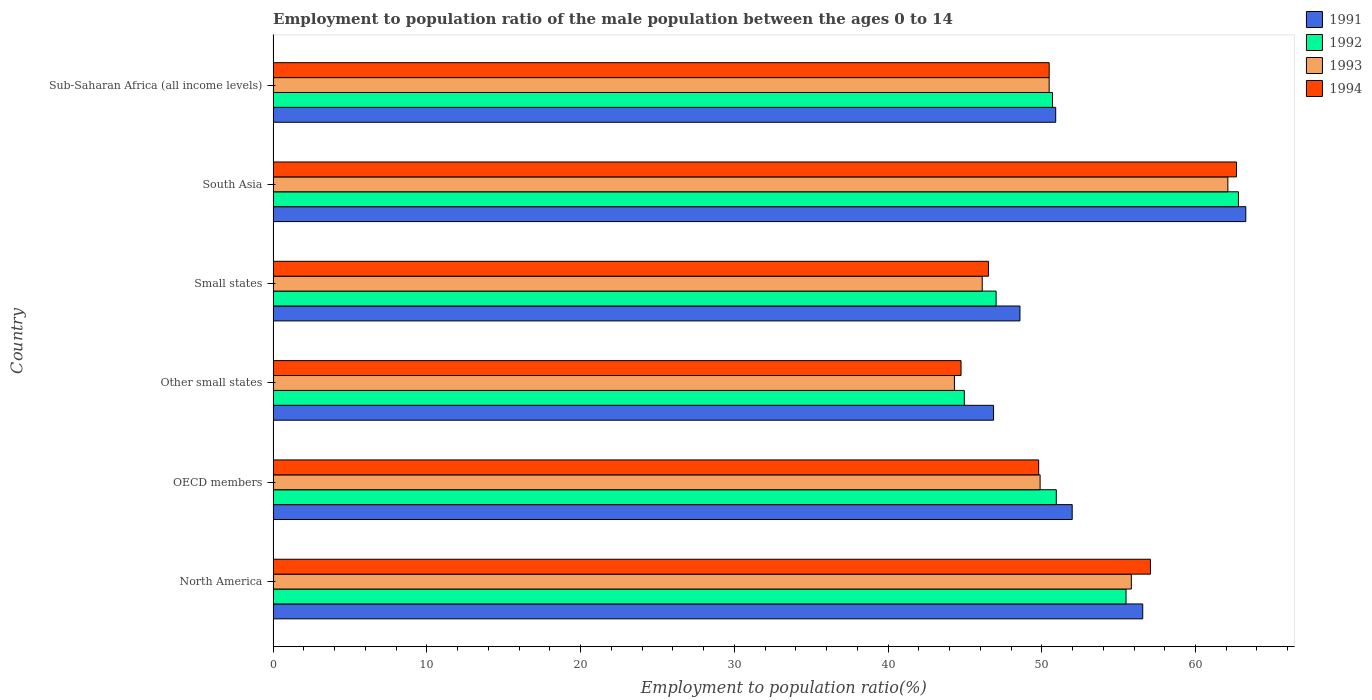How many different coloured bars are there?
Make the answer very short. 4. How many groups of bars are there?
Provide a succinct answer. 6. Are the number of bars on each tick of the Y-axis equal?
Your answer should be very brief. Yes. How many bars are there on the 3rd tick from the top?
Your answer should be very brief. 4. What is the label of the 3rd group of bars from the top?
Provide a short and direct response. Small states. What is the employment to population ratio in 1991 in Small states?
Ensure brevity in your answer.  48.58. Across all countries, what is the maximum employment to population ratio in 1991?
Ensure brevity in your answer.  63.27. Across all countries, what is the minimum employment to population ratio in 1991?
Make the answer very short. 46.86. In which country was the employment to population ratio in 1993 minimum?
Ensure brevity in your answer.  Other small states. What is the total employment to population ratio in 1992 in the graph?
Your answer should be very brief. 311.92. What is the difference between the employment to population ratio in 1992 in OECD members and that in Sub-Saharan Africa (all income levels)?
Offer a very short reply. 0.25. What is the difference between the employment to population ratio in 1991 in OECD members and the employment to population ratio in 1993 in Small states?
Keep it short and to the point. 5.85. What is the average employment to population ratio in 1993 per country?
Keep it short and to the point. 51.46. What is the difference between the employment to population ratio in 1992 and employment to population ratio in 1991 in North America?
Ensure brevity in your answer.  -1.09. In how many countries, is the employment to population ratio in 1993 greater than 4 %?
Provide a short and direct response. 6. What is the ratio of the employment to population ratio in 1994 in OECD members to that in Small states?
Make the answer very short. 1.07. Is the employment to population ratio in 1994 in OECD members less than that in Other small states?
Provide a short and direct response. No. Is the difference between the employment to population ratio in 1992 in Other small states and Small states greater than the difference between the employment to population ratio in 1991 in Other small states and Small states?
Offer a very short reply. No. What is the difference between the highest and the second highest employment to population ratio in 1991?
Give a very brief answer. 6.7. What is the difference between the highest and the lowest employment to population ratio in 1993?
Offer a very short reply. 17.79. Is the sum of the employment to population ratio in 1994 in OECD members and Sub-Saharan Africa (all income levels) greater than the maximum employment to population ratio in 1991 across all countries?
Keep it short and to the point. Yes. How many bars are there?
Make the answer very short. 24. How many countries are there in the graph?
Your response must be concise. 6. What is the difference between two consecutive major ticks on the X-axis?
Give a very brief answer. 10. Does the graph contain any zero values?
Make the answer very short. No. Does the graph contain grids?
Provide a short and direct response. No. How are the legend labels stacked?
Your answer should be compact. Vertical. What is the title of the graph?
Offer a terse response. Employment to population ratio of the male population between the ages 0 to 14. Does "1967" appear as one of the legend labels in the graph?
Ensure brevity in your answer.  No. What is the label or title of the Y-axis?
Your response must be concise. Country. What is the Employment to population ratio(%) in 1991 in North America?
Make the answer very short. 56.57. What is the Employment to population ratio(%) in 1992 in North America?
Your response must be concise. 55.48. What is the Employment to population ratio(%) in 1993 in North America?
Provide a short and direct response. 55.83. What is the Employment to population ratio(%) in 1994 in North America?
Make the answer very short. 57.07. What is the Employment to population ratio(%) of 1991 in OECD members?
Provide a short and direct response. 51.98. What is the Employment to population ratio(%) in 1992 in OECD members?
Your response must be concise. 50.95. What is the Employment to population ratio(%) of 1993 in OECD members?
Provide a succinct answer. 49.89. What is the Employment to population ratio(%) in 1994 in OECD members?
Your answer should be very brief. 49.8. What is the Employment to population ratio(%) of 1991 in Other small states?
Your answer should be compact. 46.86. What is the Employment to population ratio(%) in 1992 in Other small states?
Your answer should be very brief. 44.96. What is the Employment to population ratio(%) of 1993 in Other small states?
Your answer should be compact. 44.32. What is the Employment to population ratio(%) in 1994 in Other small states?
Ensure brevity in your answer.  44.75. What is the Employment to population ratio(%) in 1991 in Small states?
Your answer should be compact. 48.58. What is the Employment to population ratio(%) in 1992 in Small states?
Give a very brief answer. 47.03. What is the Employment to population ratio(%) of 1993 in Small states?
Your answer should be very brief. 46.13. What is the Employment to population ratio(%) of 1994 in Small states?
Offer a terse response. 46.53. What is the Employment to population ratio(%) of 1991 in South Asia?
Keep it short and to the point. 63.27. What is the Employment to population ratio(%) in 1992 in South Asia?
Ensure brevity in your answer.  62.79. What is the Employment to population ratio(%) in 1993 in South Asia?
Ensure brevity in your answer.  62.11. What is the Employment to population ratio(%) of 1994 in South Asia?
Your response must be concise. 62.67. What is the Employment to population ratio(%) of 1991 in Sub-Saharan Africa (all income levels)?
Your answer should be very brief. 50.91. What is the Employment to population ratio(%) of 1992 in Sub-Saharan Africa (all income levels)?
Offer a terse response. 50.7. What is the Employment to population ratio(%) in 1993 in Sub-Saharan Africa (all income levels)?
Give a very brief answer. 50.48. What is the Employment to population ratio(%) of 1994 in Sub-Saharan Africa (all income levels)?
Make the answer very short. 50.48. Across all countries, what is the maximum Employment to population ratio(%) of 1991?
Make the answer very short. 63.27. Across all countries, what is the maximum Employment to population ratio(%) of 1992?
Offer a terse response. 62.79. Across all countries, what is the maximum Employment to population ratio(%) in 1993?
Provide a short and direct response. 62.11. Across all countries, what is the maximum Employment to population ratio(%) of 1994?
Provide a short and direct response. 62.67. Across all countries, what is the minimum Employment to population ratio(%) in 1991?
Offer a very short reply. 46.86. Across all countries, what is the minimum Employment to population ratio(%) in 1992?
Provide a short and direct response. 44.96. Across all countries, what is the minimum Employment to population ratio(%) of 1993?
Provide a succinct answer. 44.32. Across all countries, what is the minimum Employment to population ratio(%) in 1994?
Ensure brevity in your answer.  44.75. What is the total Employment to population ratio(%) in 1991 in the graph?
Provide a short and direct response. 318.17. What is the total Employment to population ratio(%) of 1992 in the graph?
Your answer should be very brief. 311.92. What is the total Employment to population ratio(%) of 1993 in the graph?
Provide a short and direct response. 308.75. What is the total Employment to population ratio(%) in 1994 in the graph?
Your answer should be compact. 311.3. What is the difference between the Employment to population ratio(%) of 1991 in North America and that in OECD members?
Your response must be concise. 4.59. What is the difference between the Employment to population ratio(%) of 1992 in North America and that in OECD members?
Give a very brief answer. 4.54. What is the difference between the Employment to population ratio(%) of 1993 in North America and that in OECD members?
Your answer should be very brief. 5.93. What is the difference between the Employment to population ratio(%) in 1994 in North America and that in OECD members?
Make the answer very short. 7.27. What is the difference between the Employment to population ratio(%) of 1991 in North America and that in Other small states?
Keep it short and to the point. 9.7. What is the difference between the Employment to population ratio(%) of 1992 in North America and that in Other small states?
Give a very brief answer. 10.52. What is the difference between the Employment to population ratio(%) in 1993 in North America and that in Other small states?
Your answer should be compact. 11.51. What is the difference between the Employment to population ratio(%) in 1994 in North America and that in Other small states?
Your answer should be compact. 12.32. What is the difference between the Employment to population ratio(%) in 1991 in North America and that in Small states?
Your answer should be compact. 7.99. What is the difference between the Employment to population ratio(%) in 1992 in North America and that in Small states?
Keep it short and to the point. 8.45. What is the difference between the Employment to population ratio(%) of 1993 in North America and that in Small states?
Offer a terse response. 9.7. What is the difference between the Employment to population ratio(%) of 1994 in North America and that in Small states?
Your answer should be compact. 10.54. What is the difference between the Employment to population ratio(%) of 1991 in North America and that in South Asia?
Keep it short and to the point. -6.7. What is the difference between the Employment to population ratio(%) of 1992 in North America and that in South Asia?
Offer a terse response. -7.31. What is the difference between the Employment to population ratio(%) in 1993 in North America and that in South Asia?
Provide a short and direct response. -6.28. What is the difference between the Employment to population ratio(%) of 1994 in North America and that in South Asia?
Your response must be concise. -5.6. What is the difference between the Employment to population ratio(%) in 1991 in North America and that in Sub-Saharan Africa (all income levels)?
Give a very brief answer. 5.66. What is the difference between the Employment to population ratio(%) of 1992 in North America and that in Sub-Saharan Africa (all income levels)?
Keep it short and to the point. 4.78. What is the difference between the Employment to population ratio(%) in 1993 in North America and that in Sub-Saharan Africa (all income levels)?
Make the answer very short. 5.35. What is the difference between the Employment to population ratio(%) in 1994 in North America and that in Sub-Saharan Africa (all income levels)?
Keep it short and to the point. 6.59. What is the difference between the Employment to population ratio(%) of 1991 in OECD members and that in Other small states?
Provide a short and direct response. 5.12. What is the difference between the Employment to population ratio(%) in 1992 in OECD members and that in Other small states?
Offer a terse response. 5.98. What is the difference between the Employment to population ratio(%) in 1993 in OECD members and that in Other small states?
Offer a terse response. 5.57. What is the difference between the Employment to population ratio(%) in 1994 in OECD members and that in Other small states?
Your response must be concise. 5.05. What is the difference between the Employment to population ratio(%) in 1991 in OECD members and that in Small states?
Your response must be concise. 3.4. What is the difference between the Employment to population ratio(%) of 1992 in OECD members and that in Small states?
Make the answer very short. 3.91. What is the difference between the Employment to population ratio(%) in 1993 in OECD members and that in Small states?
Ensure brevity in your answer.  3.76. What is the difference between the Employment to population ratio(%) of 1994 in OECD members and that in Small states?
Offer a terse response. 3.27. What is the difference between the Employment to population ratio(%) in 1991 in OECD members and that in South Asia?
Make the answer very short. -11.29. What is the difference between the Employment to population ratio(%) of 1992 in OECD members and that in South Asia?
Make the answer very short. -11.85. What is the difference between the Employment to population ratio(%) in 1993 in OECD members and that in South Asia?
Your response must be concise. -12.21. What is the difference between the Employment to population ratio(%) of 1994 in OECD members and that in South Asia?
Ensure brevity in your answer.  -12.87. What is the difference between the Employment to population ratio(%) in 1991 in OECD members and that in Sub-Saharan Africa (all income levels)?
Your response must be concise. 1.07. What is the difference between the Employment to population ratio(%) in 1992 in OECD members and that in Sub-Saharan Africa (all income levels)?
Offer a terse response. 0.25. What is the difference between the Employment to population ratio(%) of 1993 in OECD members and that in Sub-Saharan Africa (all income levels)?
Give a very brief answer. -0.59. What is the difference between the Employment to population ratio(%) of 1994 in OECD members and that in Sub-Saharan Africa (all income levels)?
Provide a succinct answer. -0.68. What is the difference between the Employment to population ratio(%) of 1991 in Other small states and that in Small states?
Give a very brief answer. -1.72. What is the difference between the Employment to population ratio(%) in 1992 in Other small states and that in Small states?
Offer a very short reply. -2.07. What is the difference between the Employment to population ratio(%) of 1993 in Other small states and that in Small states?
Your answer should be very brief. -1.81. What is the difference between the Employment to population ratio(%) of 1994 in Other small states and that in Small states?
Make the answer very short. -1.78. What is the difference between the Employment to population ratio(%) of 1991 in Other small states and that in South Asia?
Your answer should be compact. -16.41. What is the difference between the Employment to population ratio(%) of 1992 in Other small states and that in South Asia?
Your answer should be compact. -17.83. What is the difference between the Employment to population ratio(%) of 1993 in Other small states and that in South Asia?
Keep it short and to the point. -17.79. What is the difference between the Employment to population ratio(%) in 1994 in Other small states and that in South Asia?
Make the answer very short. -17.92. What is the difference between the Employment to population ratio(%) of 1991 in Other small states and that in Sub-Saharan Africa (all income levels)?
Make the answer very short. -4.04. What is the difference between the Employment to population ratio(%) of 1992 in Other small states and that in Sub-Saharan Africa (all income levels)?
Your answer should be very brief. -5.74. What is the difference between the Employment to population ratio(%) of 1993 in Other small states and that in Sub-Saharan Africa (all income levels)?
Offer a very short reply. -6.16. What is the difference between the Employment to population ratio(%) in 1994 in Other small states and that in Sub-Saharan Africa (all income levels)?
Keep it short and to the point. -5.73. What is the difference between the Employment to population ratio(%) in 1991 in Small states and that in South Asia?
Your answer should be compact. -14.69. What is the difference between the Employment to population ratio(%) of 1992 in Small states and that in South Asia?
Your response must be concise. -15.76. What is the difference between the Employment to population ratio(%) in 1993 in Small states and that in South Asia?
Your response must be concise. -15.98. What is the difference between the Employment to population ratio(%) of 1994 in Small states and that in South Asia?
Keep it short and to the point. -16.13. What is the difference between the Employment to population ratio(%) in 1991 in Small states and that in Sub-Saharan Africa (all income levels)?
Provide a succinct answer. -2.32. What is the difference between the Employment to population ratio(%) of 1992 in Small states and that in Sub-Saharan Africa (all income levels)?
Keep it short and to the point. -3.67. What is the difference between the Employment to population ratio(%) in 1993 in Small states and that in Sub-Saharan Africa (all income levels)?
Your response must be concise. -4.35. What is the difference between the Employment to population ratio(%) of 1994 in Small states and that in Sub-Saharan Africa (all income levels)?
Provide a short and direct response. -3.95. What is the difference between the Employment to population ratio(%) of 1991 in South Asia and that in Sub-Saharan Africa (all income levels)?
Offer a very short reply. 12.37. What is the difference between the Employment to population ratio(%) in 1992 in South Asia and that in Sub-Saharan Africa (all income levels)?
Offer a terse response. 12.09. What is the difference between the Employment to population ratio(%) in 1993 in South Asia and that in Sub-Saharan Africa (all income levels)?
Provide a short and direct response. 11.62. What is the difference between the Employment to population ratio(%) in 1994 in South Asia and that in Sub-Saharan Africa (all income levels)?
Your response must be concise. 12.18. What is the difference between the Employment to population ratio(%) of 1991 in North America and the Employment to population ratio(%) of 1992 in OECD members?
Provide a succinct answer. 5.62. What is the difference between the Employment to population ratio(%) of 1991 in North America and the Employment to population ratio(%) of 1993 in OECD members?
Offer a very short reply. 6.68. What is the difference between the Employment to population ratio(%) in 1991 in North America and the Employment to population ratio(%) in 1994 in OECD members?
Your answer should be very brief. 6.77. What is the difference between the Employment to population ratio(%) in 1992 in North America and the Employment to population ratio(%) in 1993 in OECD members?
Offer a very short reply. 5.59. What is the difference between the Employment to population ratio(%) of 1992 in North America and the Employment to population ratio(%) of 1994 in OECD members?
Provide a succinct answer. 5.68. What is the difference between the Employment to population ratio(%) in 1993 in North America and the Employment to population ratio(%) in 1994 in OECD members?
Offer a very short reply. 6.03. What is the difference between the Employment to population ratio(%) in 1991 in North America and the Employment to population ratio(%) in 1992 in Other small states?
Keep it short and to the point. 11.61. What is the difference between the Employment to population ratio(%) in 1991 in North America and the Employment to population ratio(%) in 1993 in Other small states?
Make the answer very short. 12.25. What is the difference between the Employment to population ratio(%) of 1991 in North America and the Employment to population ratio(%) of 1994 in Other small states?
Provide a succinct answer. 11.82. What is the difference between the Employment to population ratio(%) in 1992 in North America and the Employment to population ratio(%) in 1993 in Other small states?
Keep it short and to the point. 11.16. What is the difference between the Employment to population ratio(%) of 1992 in North America and the Employment to population ratio(%) of 1994 in Other small states?
Your answer should be compact. 10.73. What is the difference between the Employment to population ratio(%) in 1993 in North America and the Employment to population ratio(%) in 1994 in Other small states?
Ensure brevity in your answer.  11.08. What is the difference between the Employment to population ratio(%) of 1991 in North America and the Employment to population ratio(%) of 1992 in Small states?
Provide a succinct answer. 9.54. What is the difference between the Employment to population ratio(%) of 1991 in North America and the Employment to population ratio(%) of 1993 in Small states?
Your response must be concise. 10.44. What is the difference between the Employment to population ratio(%) of 1991 in North America and the Employment to population ratio(%) of 1994 in Small states?
Your answer should be very brief. 10.04. What is the difference between the Employment to population ratio(%) of 1992 in North America and the Employment to population ratio(%) of 1993 in Small states?
Your response must be concise. 9.36. What is the difference between the Employment to population ratio(%) of 1992 in North America and the Employment to population ratio(%) of 1994 in Small states?
Keep it short and to the point. 8.95. What is the difference between the Employment to population ratio(%) of 1993 in North America and the Employment to population ratio(%) of 1994 in Small states?
Ensure brevity in your answer.  9.29. What is the difference between the Employment to population ratio(%) in 1991 in North America and the Employment to population ratio(%) in 1992 in South Asia?
Ensure brevity in your answer.  -6.23. What is the difference between the Employment to population ratio(%) of 1991 in North America and the Employment to population ratio(%) of 1993 in South Asia?
Make the answer very short. -5.54. What is the difference between the Employment to population ratio(%) in 1991 in North America and the Employment to population ratio(%) in 1994 in South Asia?
Ensure brevity in your answer.  -6.1. What is the difference between the Employment to population ratio(%) of 1992 in North America and the Employment to population ratio(%) of 1993 in South Asia?
Give a very brief answer. -6.62. What is the difference between the Employment to population ratio(%) in 1992 in North America and the Employment to population ratio(%) in 1994 in South Asia?
Ensure brevity in your answer.  -7.18. What is the difference between the Employment to population ratio(%) of 1993 in North America and the Employment to population ratio(%) of 1994 in South Asia?
Give a very brief answer. -6.84. What is the difference between the Employment to population ratio(%) in 1991 in North America and the Employment to population ratio(%) in 1992 in Sub-Saharan Africa (all income levels)?
Offer a terse response. 5.87. What is the difference between the Employment to population ratio(%) of 1991 in North America and the Employment to population ratio(%) of 1993 in Sub-Saharan Africa (all income levels)?
Keep it short and to the point. 6.09. What is the difference between the Employment to population ratio(%) of 1991 in North America and the Employment to population ratio(%) of 1994 in Sub-Saharan Africa (all income levels)?
Make the answer very short. 6.09. What is the difference between the Employment to population ratio(%) of 1992 in North America and the Employment to population ratio(%) of 1993 in Sub-Saharan Africa (all income levels)?
Give a very brief answer. 5. What is the difference between the Employment to population ratio(%) of 1992 in North America and the Employment to population ratio(%) of 1994 in Sub-Saharan Africa (all income levels)?
Provide a short and direct response. 5. What is the difference between the Employment to population ratio(%) in 1993 in North America and the Employment to population ratio(%) in 1994 in Sub-Saharan Africa (all income levels)?
Your answer should be very brief. 5.34. What is the difference between the Employment to population ratio(%) in 1991 in OECD members and the Employment to population ratio(%) in 1992 in Other small states?
Your answer should be very brief. 7.02. What is the difference between the Employment to population ratio(%) in 1991 in OECD members and the Employment to population ratio(%) in 1993 in Other small states?
Offer a terse response. 7.66. What is the difference between the Employment to population ratio(%) of 1991 in OECD members and the Employment to population ratio(%) of 1994 in Other small states?
Your response must be concise. 7.23. What is the difference between the Employment to population ratio(%) in 1992 in OECD members and the Employment to population ratio(%) in 1993 in Other small states?
Provide a succinct answer. 6.63. What is the difference between the Employment to population ratio(%) of 1992 in OECD members and the Employment to population ratio(%) of 1994 in Other small states?
Your response must be concise. 6.2. What is the difference between the Employment to population ratio(%) in 1993 in OECD members and the Employment to population ratio(%) in 1994 in Other small states?
Provide a succinct answer. 5.14. What is the difference between the Employment to population ratio(%) in 1991 in OECD members and the Employment to population ratio(%) in 1992 in Small states?
Your response must be concise. 4.95. What is the difference between the Employment to population ratio(%) of 1991 in OECD members and the Employment to population ratio(%) of 1993 in Small states?
Provide a short and direct response. 5.85. What is the difference between the Employment to population ratio(%) of 1991 in OECD members and the Employment to population ratio(%) of 1994 in Small states?
Provide a succinct answer. 5.45. What is the difference between the Employment to population ratio(%) of 1992 in OECD members and the Employment to population ratio(%) of 1993 in Small states?
Provide a short and direct response. 4.82. What is the difference between the Employment to population ratio(%) in 1992 in OECD members and the Employment to population ratio(%) in 1994 in Small states?
Provide a succinct answer. 4.41. What is the difference between the Employment to population ratio(%) of 1993 in OECD members and the Employment to population ratio(%) of 1994 in Small states?
Offer a very short reply. 3.36. What is the difference between the Employment to population ratio(%) of 1991 in OECD members and the Employment to population ratio(%) of 1992 in South Asia?
Your answer should be compact. -10.81. What is the difference between the Employment to population ratio(%) in 1991 in OECD members and the Employment to population ratio(%) in 1993 in South Asia?
Your response must be concise. -10.13. What is the difference between the Employment to population ratio(%) of 1991 in OECD members and the Employment to population ratio(%) of 1994 in South Asia?
Provide a succinct answer. -10.69. What is the difference between the Employment to population ratio(%) of 1992 in OECD members and the Employment to population ratio(%) of 1993 in South Asia?
Your answer should be very brief. -11.16. What is the difference between the Employment to population ratio(%) in 1992 in OECD members and the Employment to population ratio(%) in 1994 in South Asia?
Your answer should be very brief. -11.72. What is the difference between the Employment to population ratio(%) in 1993 in OECD members and the Employment to population ratio(%) in 1994 in South Asia?
Keep it short and to the point. -12.77. What is the difference between the Employment to population ratio(%) of 1991 in OECD members and the Employment to population ratio(%) of 1992 in Sub-Saharan Africa (all income levels)?
Your answer should be very brief. 1.28. What is the difference between the Employment to population ratio(%) in 1991 in OECD members and the Employment to population ratio(%) in 1993 in Sub-Saharan Africa (all income levels)?
Provide a succinct answer. 1.5. What is the difference between the Employment to population ratio(%) in 1991 in OECD members and the Employment to population ratio(%) in 1994 in Sub-Saharan Africa (all income levels)?
Offer a very short reply. 1.5. What is the difference between the Employment to population ratio(%) of 1992 in OECD members and the Employment to population ratio(%) of 1993 in Sub-Saharan Africa (all income levels)?
Your answer should be very brief. 0.47. What is the difference between the Employment to population ratio(%) of 1992 in OECD members and the Employment to population ratio(%) of 1994 in Sub-Saharan Africa (all income levels)?
Give a very brief answer. 0.46. What is the difference between the Employment to population ratio(%) in 1993 in OECD members and the Employment to population ratio(%) in 1994 in Sub-Saharan Africa (all income levels)?
Offer a very short reply. -0.59. What is the difference between the Employment to population ratio(%) of 1991 in Other small states and the Employment to population ratio(%) of 1992 in Small states?
Give a very brief answer. -0.17. What is the difference between the Employment to population ratio(%) in 1991 in Other small states and the Employment to population ratio(%) in 1993 in Small states?
Your answer should be very brief. 0.74. What is the difference between the Employment to population ratio(%) in 1991 in Other small states and the Employment to population ratio(%) in 1994 in Small states?
Your response must be concise. 0.33. What is the difference between the Employment to population ratio(%) in 1992 in Other small states and the Employment to population ratio(%) in 1993 in Small states?
Provide a succinct answer. -1.16. What is the difference between the Employment to population ratio(%) in 1992 in Other small states and the Employment to population ratio(%) in 1994 in Small states?
Offer a terse response. -1.57. What is the difference between the Employment to population ratio(%) in 1993 in Other small states and the Employment to population ratio(%) in 1994 in Small states?
Keep it short and to the point. -2.21. What is the difference between the Employment to population ratio(%) of 1991 in Other small states and the Employment to population ratio(%) of 1992 in South Asia?
Offer a terse response. -15.93. What is the difference between the Employment to population ratio(%) of 1991 in Other small states and the Employment to population ratio(%) of 1993 in South Asia?
Your answer should be very brief. -15.24. What is the difference between the Employment to population ratio(%) of 1991 in Other small states and the Employment to population ratio(%) of 1994 in South Asia?
Give a very brief answer. -15.8. What is the difference between the Employment to population ratio(%) of 1992 in Other small states and the Employment to population ratio(%) of 1993 in South Asia?
Make the answer very short. -17.14. What is the difference between the Employment to population ratio(%) of 1992 in Other small states and the Employment to population ratio(%) of 1994 in South Asia?
Offer a very short reply. -17.7. What is the difference between the Employment to population ratio(%) in 1993 in Other small states and the Employment to population ratio(%) in 1994 in South Asia?
Give a very brief answer. -18.35. What is the difference between the Employment to population ratio(%) of 1991 in Other small states and the Employment to population ratio(%) of 1992 in Sub-Saharan Africa (all income levels)?
Offer a very short reply. -3.84. What is the difference between the Employment to population ratio(%) of 1991 in Other small states and the Employment to population ratio(%) of 1993 in Sub-Saharan Africa (all income levels)?
Make the answer very short. -3.62. What is the difference between the Employment to population ratio(%) of 1991 in Other small states and the Employment to population ratio(%) of 1994 in Sub-Saharan Africa (all income levels)?
Your response must be concise. -3.62. What is the difference between the Employment to population ratio(%) in 1992 in Other small states and the Employment to population ratio(%) in 1993 in Sub-Saharan Africa (all income levels)?
Make the answer very short. -5.52. What is the difference between the Employment to population ratio(%) in 1992 in Other small states and the Employment to population ratio(%) in 1994 in Sub-Saharan Africa (all income levels)?
Your answer should be compact. -5.52. What is the difference between the Employment to population ratio(%) of 1993 in Other small states and the Employment to population ratio(%) of 1994 in Sub-Saharan Africa (all income levels)?
Your answer should be compact. -6.16. What is the difference between the Employment to population ratio(%) of 1991 in Small states and the Employment to population ratio(%) of 1992 in South Asia?
Your answer should be very brief. -14.21. What is the difference between the Employment to population ratio(%) of 1991 in Small states and the Employment to population ratio(%) of 1993 in South Asia?
Offer a terse response. -13.52. What is the difference between the Employment to population ratio(%) of 1991 in Small states and the Employment to population ratio(%) of 1994 in South Asia?
Your answer should be very brief. -14.08. What is the difference between the Employment to population ratio(%) of 1992 in Small states and the Employment to population ratio(%) of 1993 in South Asia?
Ensure brevity in your answer.  -15.07. What is the difference between the Employment to population ratio(%) of 1992 in Small states and the Employment to population ratio(%) of 1994 in South Asia?
Give a very brief answer. -15.63. What is the difference between the Employment to population ratio(%) of 1993 in Small states and the Employment to population ratio(%) of 1994 in South Asia?
Your answer should be compact. -16.54. What is the difference between the Employment to population ratio(%) in 1991 in Small states and the Employment to population ratio(%) in 1992 in Sub-Saharan Africa (all income levels)?
Ensure brevity in your answer.  -2.12. What is the difference between the Employment to population ratio(%) in 1991 in Small states and the Employment to population ratio(%) in 1993 in Sub-Saharan Africa (all income levels)?
Your answer should be very brief. -1.9. What is the difference between the Employment to population ratio(%) of 1991 in Small states and the Employment to population ratio(%) of 1994 in Sub-Saharan Africa (all income levels)?
Provide a short and direct response. -1.9. What is the difference between the Employment to population ratio(%) of 1992 in Small states and the Employment to population ratio(%) of 1993 in Sub-Saharan Africa (all income levels)?
Ensure brevity in your answer.  -3.45. What is the difference between the Employment to population ratio(%) of 1992 in Small states and the Employment to population ratio(%) of 1994 in Sub-Saharan Africa (all income levels)?
Your response must be concise. -3.45. What is the difference between the Employment to population ratio(%) in 1993 in Small states and the Employment to population ratio(%) in 1994 in Sub-Saharan Africa (all income levels)?
Keep it short and to the point. -4.36. What is the difference between the Employment to population ratio(%) of 1991 in South Asia and the Employment to population ratio(%) of 1992 in Sub-Saharan Africa (all income levels)?
Give a very brief answer. 12.57. What is the difference between the Employment to population ratio(%) of 1991 in South Asia and the Employment to population ratio(%) of 1993 in Sub-Saharan Africa (all income levels)?
Ensure brevity in your answer.  12.79. What is the difference between the Employment to population ratio(%) of 1991 in South Asia and the Employment to population ratio(%) of 1994 in Sub-Saharan Africa (all income levels)?
Give a very brief answer. 12.79. What is the difference between the Employment to population ratio(%) in 1992 in South Asia and the Employment to population ratio(%) in 1993 in Sub-Saharan Africa (all income levels)?
Ensure brevity in your answer.  12.31. What is the difference between the Employment to population ratio(%) in 1992 in South Asia and the Employment to population ratio(%) in 1994 in Sub-Saharan Africa (all income levels)?
Give a very brief answer. 12.31. What is the difference between the Employment to population ratio(%) in 1993 in South Asia and the Employment to population ratio(%) in 1994 in Sub-Saharan Africa (all income levels)?
Give a very brief answer. 11.62. What is the average Employment to population ratio(%) in 1991 per country?
Keep it short and to the point. 53.03. What is the average Employment to population ratio(%) in 1992 per country?
Keep it short and to the point. 51.99. What is the average Employment to population ratio(%) of 1993 per country?
Give a very brief answer. 51.46. What is the average Employment to population ratio(%) of 1994 per country?
Offer a very short reply. 51.88. What is the difference between the Employment to population ratio(%) of 1991 and Employment to population ratio(%) of 1992 in North America?
Make the answer very short. 1.09. What is the difference between the Employment to population ratio(%) in 1991 and Employment to population ratio(%) in 1993 in North America?
Offer a terse response. 0.74. What is the difference between the Employment to population ratio(%) of 1991 and Employment to population ratio(%) of 1994 in North America?
Make the answer very short. -0.5. What is the difference between the Employment to population ratio(%) of 1992 and Employment to population ratio(%) of 1993 in North America?
Keep it short and to the point. -0.34. What is the difference between the Employment to population ratio(%) in 1992 and Employment to population ratio(%) in 1994 in North America?
Provide a short and direct response. -1.59. What is the difference between the Employment to population ratio(%) of 1993 and Employment to population ratio(%) of 1994 in North America?
Give a very brief answer. -1.24. What is the difference between the Employment to population ratio(%) of 1991 and Employment to population ratio(%) of 1992 in OECD members?
Offer a terse response. 1.03. What is the difference between the Employment to population ratio(%) of 1991 and Employment to population ratio(%) of 1993 in OECD members?
Provide a succinct answer. 2.09. What is the difference between the Employment to population ratio(%) in 1991 and Employment to population ratio(%) in 1994 in OECD members?
Your answer should be very brief. 2.18. What is the difference between the Employment to population ratio(%) in 1992 and Employment to population ratio(%) in 1993 in OECD members?
Offer a very short reply. 1.05. What is the difference between the Employment to population ratio(%) in 1992 and Employment to population ratio(%) in 1994 in OECD members?
Your response must be concise. 1.15. What is the difference between the Employment to population ratio(%) of 1993 and Employment to population ratio(%) of 1994 in OECD members?
Your answer should be compact. 0.09. What is the difference between the Employment to population ratio(%) in 1991 and Employment to population ratio(%) in 1992 in Other small states?
Give a very brief answer. 1.9. What is the difference between the Employment to population ratio(%) in 1991 and Employment to population ratio(%) in 1993 in Other small states?
Offer a very short reply. 2.54. What is the difference between the Employment to population ratio(%) of 1991 and Employment to population ratio(%) of 1994 in Other small states?
Give a very brief answer. 2.11. What is the difference between the Employment to population ratio(%) of 1992 and Employment to population ratio(%) of 1993 in Other small states?
Offer a very short reply. 0.64. What is the difference between the Employment to population ratio(%) of 1992 and Employment to population ratio(%) of 1994 in Other small states?
Your answer should be compact. 0.21. What is the difference between the Employment to population ratio(%) in 1993 and Employment to population ratio(%) in 1994 in Other small states?
Offer a very short reply. -0.43. What is the difference between the Employment to population ratio(%) in 1991 and Employment to population ratio(%) in 1992 in Small states?
Keep it short and to the point. 1.55. What is the difference between the Employment to population ratio(%) of 1991 and Employment to population ratio(%) of 1993 in Small states?
Give a very brief answer. 2.45. What is the difference between the Employment to population ratio(%) of 1991 and Employment to population ratio(%) of 1994 in Small states?
Ensure brevity in your answer.  2.05. What is the difference between the Employment to population ratio(%) in 1992 and Employment to population ratio(%) in 1993 in Small states?
Keep it short and to the point. 0.9. What is the difference between the Employment to population ratio(%) in 1992 and Employment to population ratio(%) in 1994 in Small states?
Your answer should be compact. 0.5. What is the difference between the Employment to population ratio(%) in 1993 and Employment to population ratio(%) in 1994 in Small states?
Provide a short and direct response. -0.4. What is the difference between the Employment to population ratio(%) in 1991 and Employment to population ratio(%) in 1992 in South Asia?
Provide a short and direct response. 0.48. What is the difference between the Employment to population ratio(%) of 1991 and Employment to population ratio(%) of 1993 in South Asia?
Ensure brevity in your answer.  1.17. What is the difference between the Employment to population ratio(%) of 1991 and Employment to population ratio(%) of 1994 in South Asia?
Make the answer very short. 0.61. What is the difference between the Employment to population ratio(%) of 1992 and Employment to population ratio(%) of 1993 in South Asia?
Keep it short and to the point. 0.69. What is the difference between the Employment to population ratio(%) of 1992 and Employment to population ratio(%) of 1994 in South Asia?
Provide a short and direct response. 0.13. What is the difference between the Employment to population ratio(%) in 1993 and Employment to population ratio(%) in 1994 in South Asia?
Provide a succinct answer. -0.56. What is the difference between the Employment to population ratio(%) in 1991 and Employment to population ratio(%) in 1992 in Sub-Saharan Africa (all income levels)?
Make the answer very short. 0.21. What is the difference between the Employment to population ratio(%) in 1991 and Employment to population ratio(%) in 1993 in Sub-Saharan Africa (all income levels)?
Provide a short and direct response. 0.43. What is the difference between the Employment to population ratio(%) in 1991 and Employment to population ratio(%) in 1994 in Sub-Saharan Africa (all income levels)?
Your answer should be very brief. 0.42. What is the difference between the Employment to population ratio(%) in 1992 and Employment to population ratio(%) in 1993 in Sub-Saharan Africa (all income levels)?
Your answer should be very brief. 0.22. What is the difference between the Employment to population ratio(%) of 1992 and Employment to population ratio(%) of 1994 in Sub-Saharan Africa (all income levels)?
Provide a short and direct response. 0.22. What is the difference between the Employment to population ratio(%) of 1993 and Employment to population ratio(%) of 1994 in Sub-Saharan Africa (all income levels)?
Make the answer very short. -0. What is the ratio of the Employment to population ratio(%) in 1991 in North America to that in OECD members?
Provide a short and direct response. 1.09. What is the ratio of the Employment to population ratio(%) in 1992 in North America to that in OECD members?
Your answer should be very brief. 1.09. What is the ratio of the Employment to population ratio(%) of 1993 in North America to that in OECD members?
Provide a succinct answer. 1.12. What is the ratio of the Employment to population ratio(%) in 1994 in North America to that in OECD members?
Give a very brief answer. 1.15. What is the ratio of the Employment to population ratio(%) of 1991 in North America to that in Other small states?
Keep it short and to the point. 1.21. What is the ratio of the Employment to population ratio(%) of 1992 in North America to that in Other small states?
Keep it short and to the point. 1.23. What is the ratio of the Employment to population ratio(%) in 1993 in North America to that in Other small states?
Your response must be concise. 1.26. What is the ratio of the Employment to population ratio(%) in 1994 in North America to that in Other small states?
Offer a very short reply. 1.28. What is the ratio of the Employment to population ratio(%) of 1991 in North America to that in Small states?
Ensure brevity in your answer.  1.16. What is the ratio of the Employment to population ratio(%) in 1992 in North America to that in Small states?
Your response must be concise. 1.18. What is the ratio of the Employment to population ratio(%) in 1993 in North America to that in Small states?
Your answer should be very brief. 1.21. What is the ratio of the Employment to population ratio(%) of 1994 in North America to that in Small states?
Your answer should be very brief. 1.23. What is the ratio of the Employment to population ratio(%) of 1991 in North America to that in South Asia?
Offer a terse response. 0.89. What is the ratio of the Employment to population ratio(%) of 1992 in North America to that in South Asia?
Your answer should be compact. 0.88. What is the ratio of the Employment to population ratio(%) of 1993 in North America to that in South Asia?
Your answer should be compact. 0.9. What is the ratio of the Employment to population ratio(%) in 1994 in North America to that in South Asia?
Your answer should be very brief. 0.91. What is the ratio of the Employment to population ratio(%) in 1991 in North America to that in Sub-Saharan Africa (all income levels)?
Ensure brevity in your answer.  1.11. What is the ratio of the Employment to population ratio(%) in 1992 in North America to that in Sub-Saharan Africa (all income levels)?
Your response must be concise. 1.09. What is the ratio of the Employment to population ratio(%) of 1993 in North America to that in Sub-Saharan Africa (all income levels)?
Your answer should be compact. 1.11. What is the ratio of the Employment to population ratio(%) of 1994 in North America to that in Sub-Saharan Africa (all income levels)?
Offer a very short reply. 1.13. What is the ratio of the Employment to population ratio(%) in 1991 in OECD members to that in Other small states?
Give a very brief answer. 1.11. What is the ratio of the Employment to population ratio(%) of 1992 in OECD members to that in Other small states?
Your answer should be compact. 1.13. What is the ratio of the Employment to population ratio(%) of 1993 in OECD members to that in Other small states?
Your answer should be compact. 1.13. What is the ratio of the Employment to population ratio(%) of 1994 in OECD members to that in Other small states?
Keep it short and to the point. 1.11. What is the ratio of the Employment to population ratio(%) in 1991 in OECD members to that in Small states?
Offer a very short reply. 1.07. What is the ratio of the Employment to population ratio(%) in 1992 in OECD members to that in Small states?
Your answer should be very brief. 1.08. What is the ratio of the Employment to population ratio(%) of 1993 in OECD members to that in Small states?
Make the answer very short. 1.08. What is the ratio of the Employment to population ratio(%) in 1994 in OECD members to that in Small states?
Ensure brevity in your answer.  1.07. What is the ratio of the Employment to population ratio(%) in 1991 in OECD members to that in South Asia?
Offer a terse response. 0.82. What is the ratio of the Employment to population ratio(%) of 1992 in OECD members to that in South Asia?
Your answer should be compact. 0.81. What is the ratio of the Employment to population ratio(%) in 1993 in OECD members to that in South Asia?
Keep it short and to the point. 0.8. What is the ratio of the Employment to population ratio(%) of 1994 in OECD members to that in South Asia?
Give a very brief answer. 0.79. What is the ratio of the Employment to population ratio(%) of 1991 in OECD members to that in Sub-Saharan Africa (all income levels)?
Your response must be concise. 1.02. What is the ratio of the Employment to population ratio(%) in 1993 in OECD members to that in Sub-Saharan Africa (all income levels)?
Provide a succinct answer. 0.99. What is the ratio of the Employment to population ratio(%) in 1994 in OECD members to that in Sub-Saharan Africa (all income levels)?
Keep it short and to the point. 0.99. What is the ratio of the Employment to population ratio(%) of 1991 in Other small states to that in Small states?
Keep it short and to the point. 0.96. What is the ratio of the Employment to population ratio(%) of 1992 in Other small states to that in Small states?
Offer a very short reply. 0.96. What is the ratio of the Employment to population ratio(%) in 1993 in Other small states to that in Small states?
Keep it short and to the point. 0.96. What is the ratio of the Employment to population ratio(%) of 1994 in Other small states to that in Small states?
Your answer should be compact. 0.96. What is the ratio of the Employment to population ratio(%) of 1991 in Other small states to that in South Asia?
Give a very brief answer. 0.74. What is the ratio of the Employment to population ratio(%) in 1992 in Other small states to that in South Asia?
Keep it short and to the point. 0.72. What is the ratio of the Employment to population ratio(%) of 1993 in Other small states to that in South Asia?
Provide a short and direct response. 0.71. What is the ratio of the Employment to population ratio(%) in 1994 in Other small states to that in South Asia?
Give a very brief answer. 0.71. What is the ratio of the Employment to population ratio(%) in 1991 in Other small states to that in Sub-Saharan Africa (all income levels)?
Provide a short and direct response. 0.92. What is the ratio of the Employment to population ratio(%) of 1992 in Other small states to that in Sub-Saharan Africa (all income levels)?
Make the answer very short. 0.89. What is the ratio of the Employment to population ratio(%) in 1993 in Other small states to that in Sub-Saharan Africa (all income levels)?
Make the answer very short. 0.88. What is the ratio of the Employment to population ratio(%) of 1994 in Other small states to that in Sub-Saharan Africa (all income levels)?
Provide a short and direct response. 0.89. What is the ratio of the Employment to population ratio(%) in 1991 in Small states to that in South Asia?
Make the answer very short. 0.77. What is the ratio of the Employment to population ratio(%) in 1992 in Small states to that in South Asia?
Your response must be concise. 0.75. What is the ratio of the Employment to population ratio(%) in 1993 in Small states to that in South Asia?
Ensure brevity in your answer.  0.74. What is the ratio of the Employment to population ratio(%) in 1994 in Small states to that in South Asia?
Your answer should be compact. 0.74. What is the ratio of the Employment to population ratio(%) of 1991 in Small states to that in Sub-Saharan Africa (all income levels)?
Provide a succinct answer. 0.95. What is the ratio of the Employment to population ratio(%) in 1992 in Small states to that in Sub-Saharan Africa (all income levels)?
Make the answer very short. 0.93. What is the ratio of the Employment to population ratio(%) in 1993 in Small states to that in Sub-Saharan Africa (all income levels)?
Make the answer very short. 0.91. What is the ratio of the Employment to population ratio(%) of 1994 in Small states to that in Sub-Saharan Africa (all income levels)?
Offer a terse response. 0.92. What is the ratio of the Employment to population ratio(%) in 1991 in South Asia to that in Sub-Saharan Africa (all income levels)?
Give a very brief answer. 1.24. What is the ratio of the Employment to population ratio(%) in 1992 in South Asia to that in Sub-Saharan Africa (all income levels)?
Give a very brief answer. 1.24. What is the ratio of the Employment to population ratio(%) in 1993 in South Asia to that in Sub-Saharan Africa (all income levels)?
Keep it short and to the point. 1.23. What is the ratio of the Employment to population ratio(%) of 1994 in South Asia to that in Sub-Saharan Africa (all income levels)?
Ensure brevity in your answer.  1.24. What is the difference between the highest and the second highest Employment to population ratio(%) of 1991?
Your response must be concise. 6.7. What is the difference between the highest and the second highest Employment to population ratio(%) of 1992?
Offer a very short reply. 7.31. What is the difference between the highest and the second highest Employment to population ratio(%) of 1993?
Make the answer very short. 6.28. What is the difference between the highest and the second highest Employment to population ratio(%) in 1994?
Give a very brief answer. 5.6. What is the difference between the highest and the lowest Employment to population ratio(%) in 1991?
Make the answer very short. 16.41. What is the difference between the highest and the lowest Employment to population ratio(%) of 1992?
Ensure brevity in your answer.  17.83. What is the difference between the highest and the lowest Employment to population ratio(%) in 1993?
Provide a short and direct response. 17.79. What is the difference between the highest and the lowest Employment to population ratio(%) in 1994?
Your answer should be compact. 17.92. 